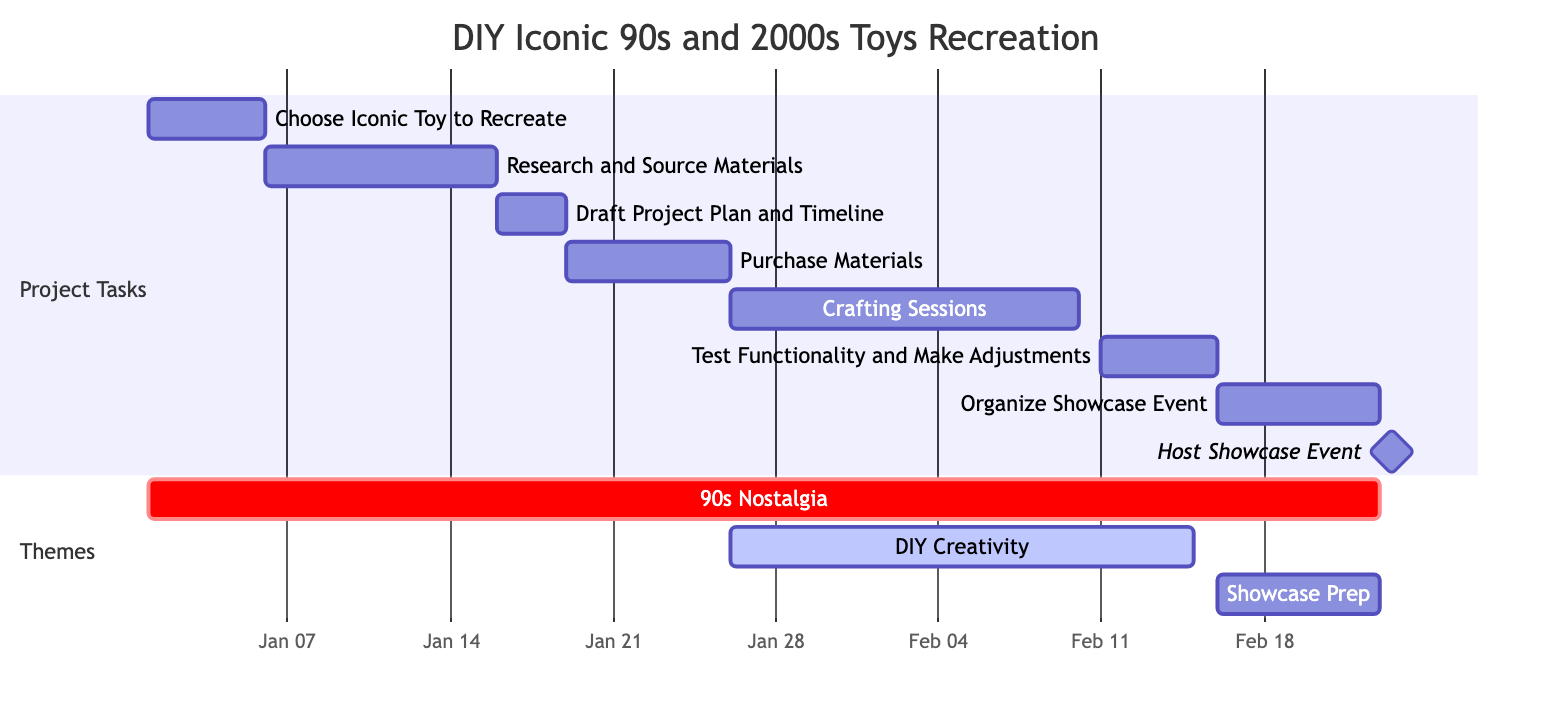What is the total duration of the project? The project’s duration can be calculated by looking at the start date of the first task and the end date of the last task. The first task starts on January 1, 2024, and the last task (Host Showcase Event) ends on February 23, 2024. The total duration is therefore 53 days.
Answer: 53 days How long is the crafting session scheduled for? The crafting sessions start on January 26, 2024, and end on February 10, 2024. This spans a total of 15 days, as indicated by the duration of the related task.
Answer: 15 days Which task is the first to occur? The first task in the project schedule is "Choose Iconic Toy to Recreate," which begins on January 1, 2024. This can be noted as it is the starting node in the Gantt chart.
Answer: Choose Iconic Toy to Recreate What task follows "Research and Source Materials"? After "Research and Source Materials," which ends on January 15, 2024, the next task is "Draft Project Plan and Timeline," starting on January 16, 2024. This can be deduced by reviewing the timeline of the tasks.
Answer: Draft Project Plan and Timeline What is the timeline for the 'Organize Showcase Event'? The "Organize Showcase Event" task starts on February 16, 2024, and ends on February 22, 2024. Thus, it occupies a week's time in the schedule. The details of the event can be found directly in the chart according to its designated dates.
Answer: February 16 to February 22, 2024 How many total tasks are included in the project? The total number of tasks can be determined by counting the individual tasks listed in the Gantt chart. There are 8 tasks outlined for this project, as denoted in the tasks section of the diagram.
Answer: 8 tasks Which task has the shortest duration? The task "Host Showcase Event" has a duration of 1 day, as it is a milestone event and scheduled for only February 23, 2024. This is the quick reference one would find by comparing all task durations listed.
Answer: 1 day What is the essence of the 'Themes' section in the chart? The 'Themes' section includes categories that organize related tasks such as "90s Nostalgia" covering the entire project duration and "DIY Creativity," which emphasizes the crafting phase. This context can be gathered by reading through the themes defined with their respective date ranges on the Gantt chart.
Answer: Project Themes What is the subsequent task after “Test Functionality and Make Adjustments”? Following the “Test Functionality and Make Adjustments” task, which ends on February 15, 2024, the next task is "Organize Showcase Event," commencing the following day. This sequencing aligns with the task timelines displayed sequentially in the Gantt chart.
Answer: Organize Showcase Event 